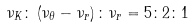Convert formula to latex. <formula><loc_0><loc_0><loc_500><loc_500>\nu _ { K } \colon \left ( \nu _ { \theta } - \nu _ { r } \right ) \colon \nu _ { r } = 5 \colon 2 \colon 1</formula> 